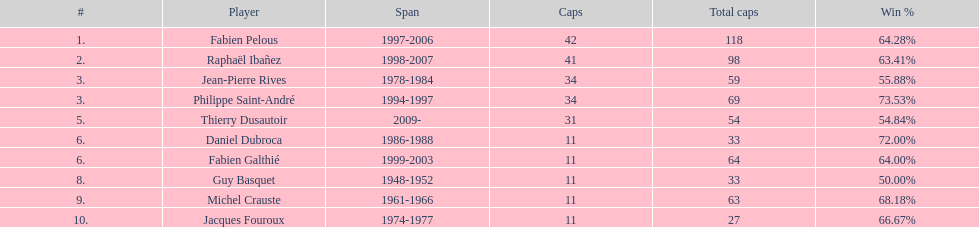How many caps did jean-pierre rives and michel crauste accrue? 122. 